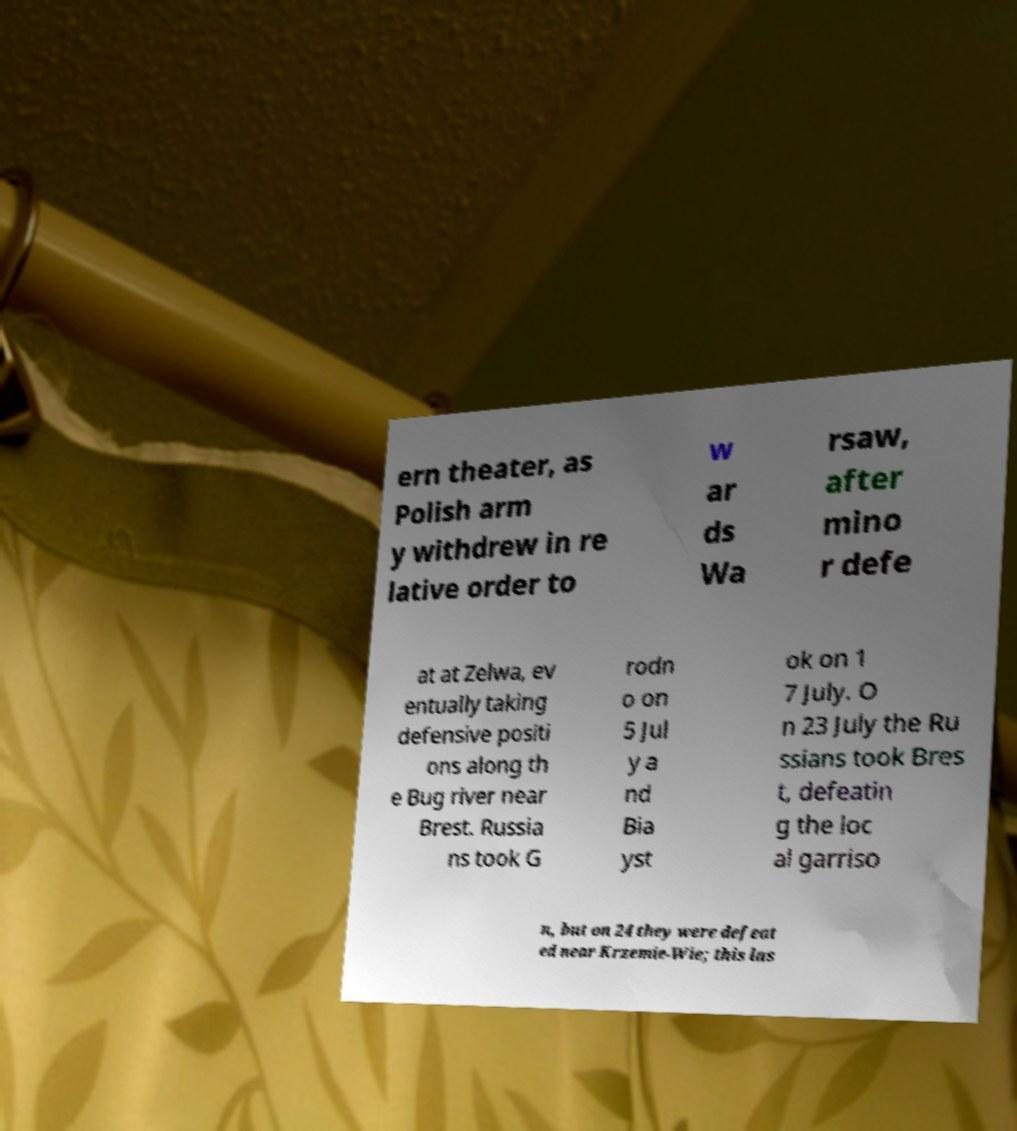Please read and relay the text visible in this image. What does it say? ern theater, as Polish arm y withdrew in re lative order to w ar ds Wa rsaw, after mino r defe at at Zelwa, ev entually taking defensive positi ons along th e Bug river near Brest. Russia ns took G rodn o on 5 Jul y a nd Bia yst ok on 1 7 July. O n 23 July the Ru ssians took Bres t, defeatin g the loc al garriso n, but on 24 they were defeat ed near Krzemie-Wie; this las 